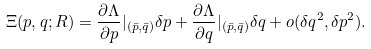Convert formula to latex. <formula><loc_0><loc_0><loc_500><loc_500>\Xi ( p , q ; R ) = \frac { \partial \Lambda } { \partial p } | _ { ( \bar { p } , \bar { q } ) } \delta p + \frac { \partial \Lambda } { \partial q } | _ { ( \bar { p } , \bar { q } ) } \delta q + o ( \delta q ^ { 2 } , \delta p ^ { 2 } ) .</formula> 